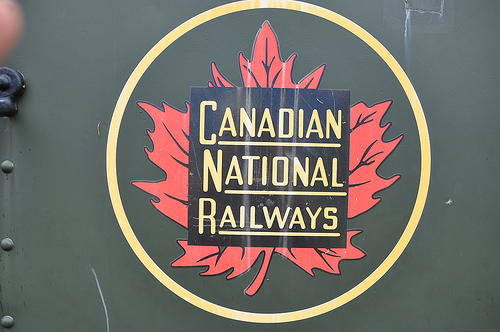<image>
Is the leaf in front of the paper? No. The leaf is not in front of the paper. The spatial positioning shows a different relationship between these objects. 